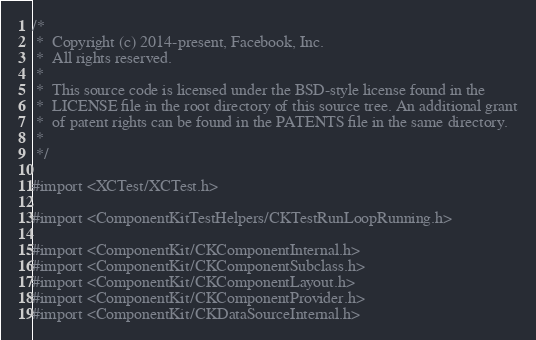<code> <loc_0><loc_0><loc_500><loc_500><_ObjectiveC_>/*
 *  Copyright (c) 2014-present, Facebook, Inc.
 *  All rights reserved.
 *
 *  This source code is licensed under the BSD-style license found in the
 *  LICENSE file in the root directory of this source tree. An additional grant
 *  of patent rights can be found in the PATENTS file in the same directory.
 *
 */

#import <XCTest/XCTest.h>

#import <ComponentKitTestHelpers/CKTestRunLoopRunning.h>

#import <ComponentKit/CKComponentInternal.h>
#import <ComponentKit/CKComponentSubclass.h>
#import <ComponentKit/CKComponentLayout.h>
#import <ComponentKit/CKComponentProvider.h>
#import <ComponentKit/CKDataSourceInternal.h></code> 